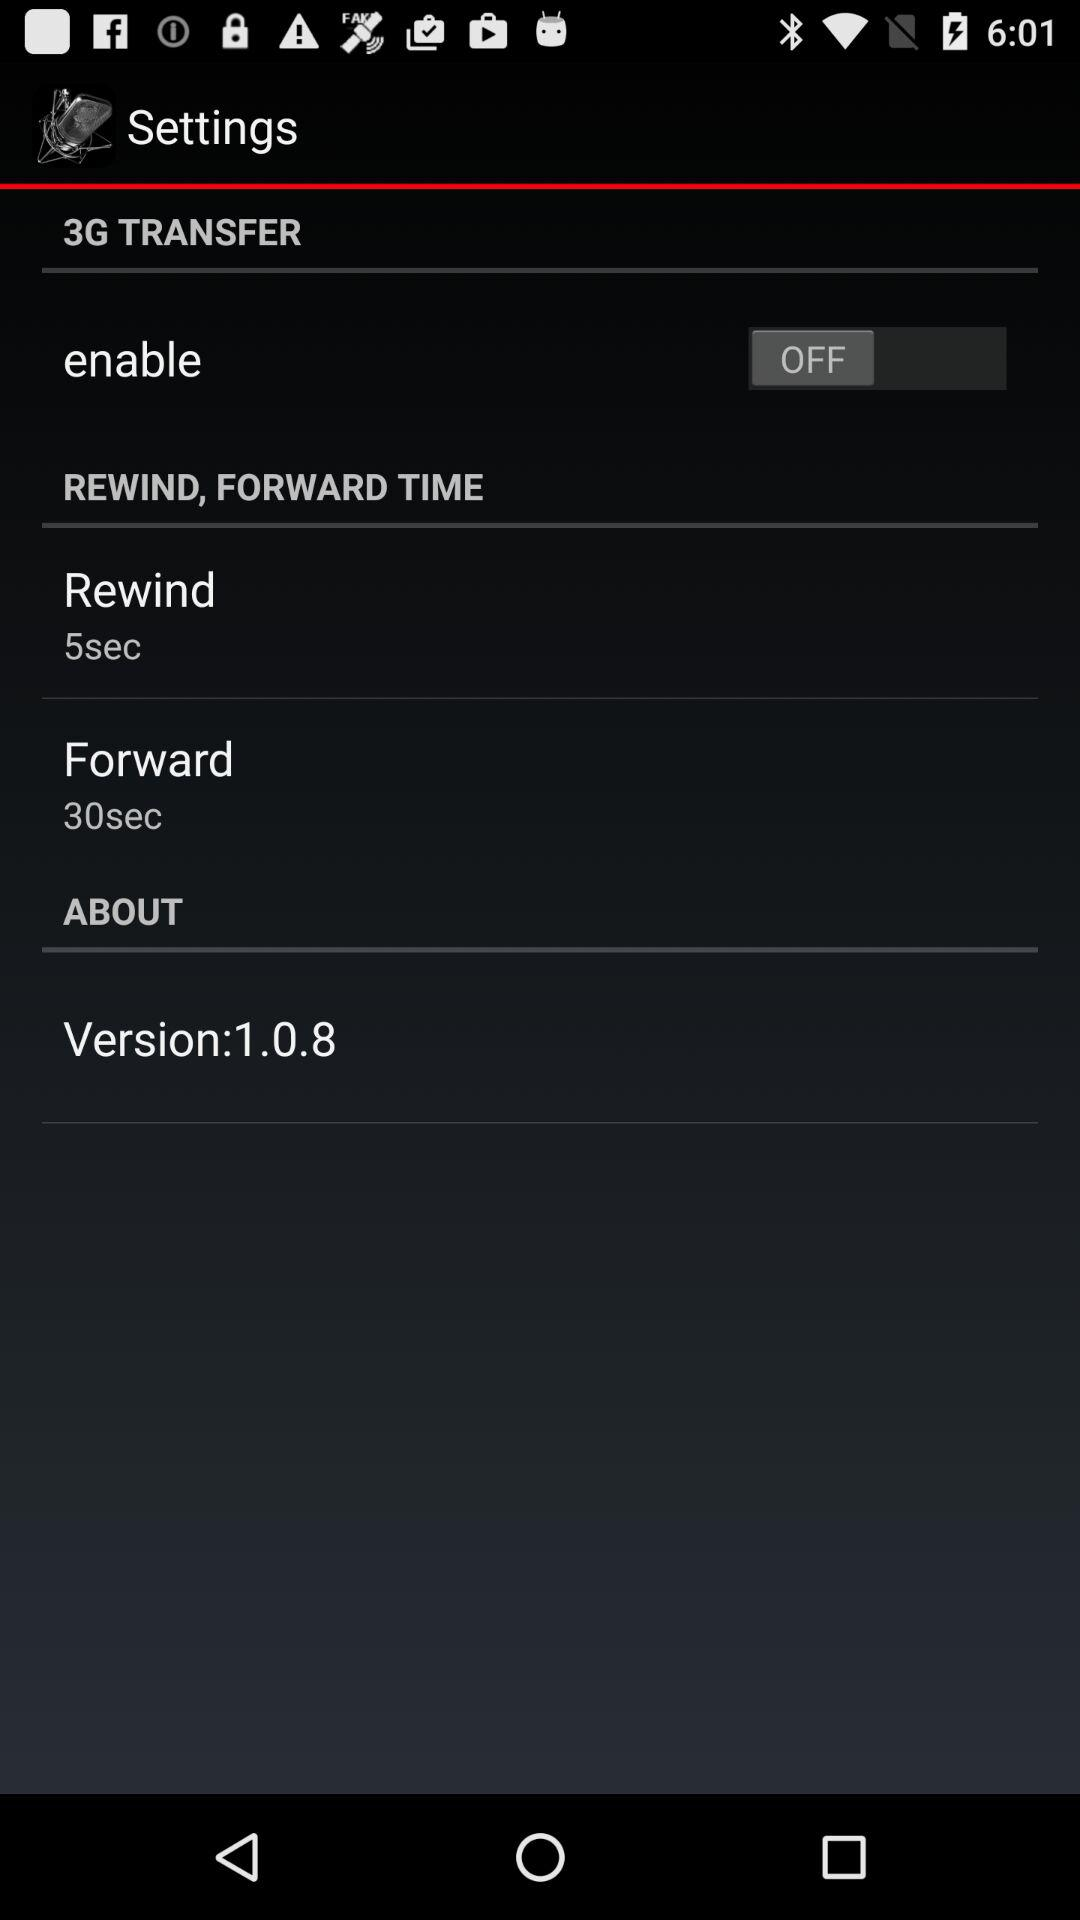When was the version updated?
When the provided information is insufficient, respond with <no answer>. <no answer> 